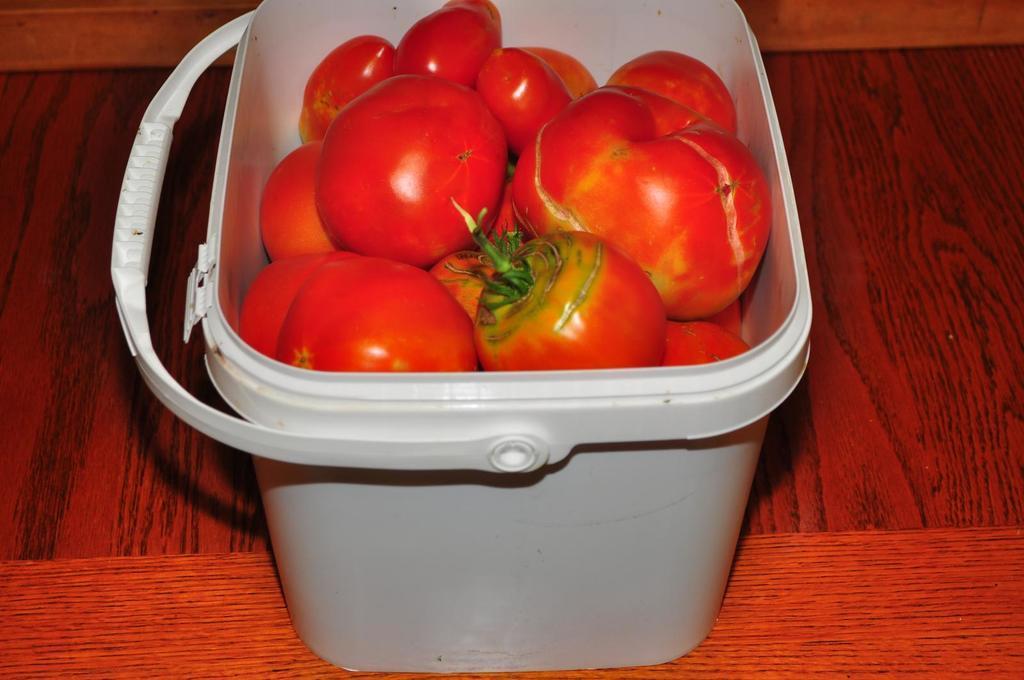Describe this image in one or two sentences. In this image I can see few tomatoes in red color. They are in basket. The basket is on the brown and red color surface. 